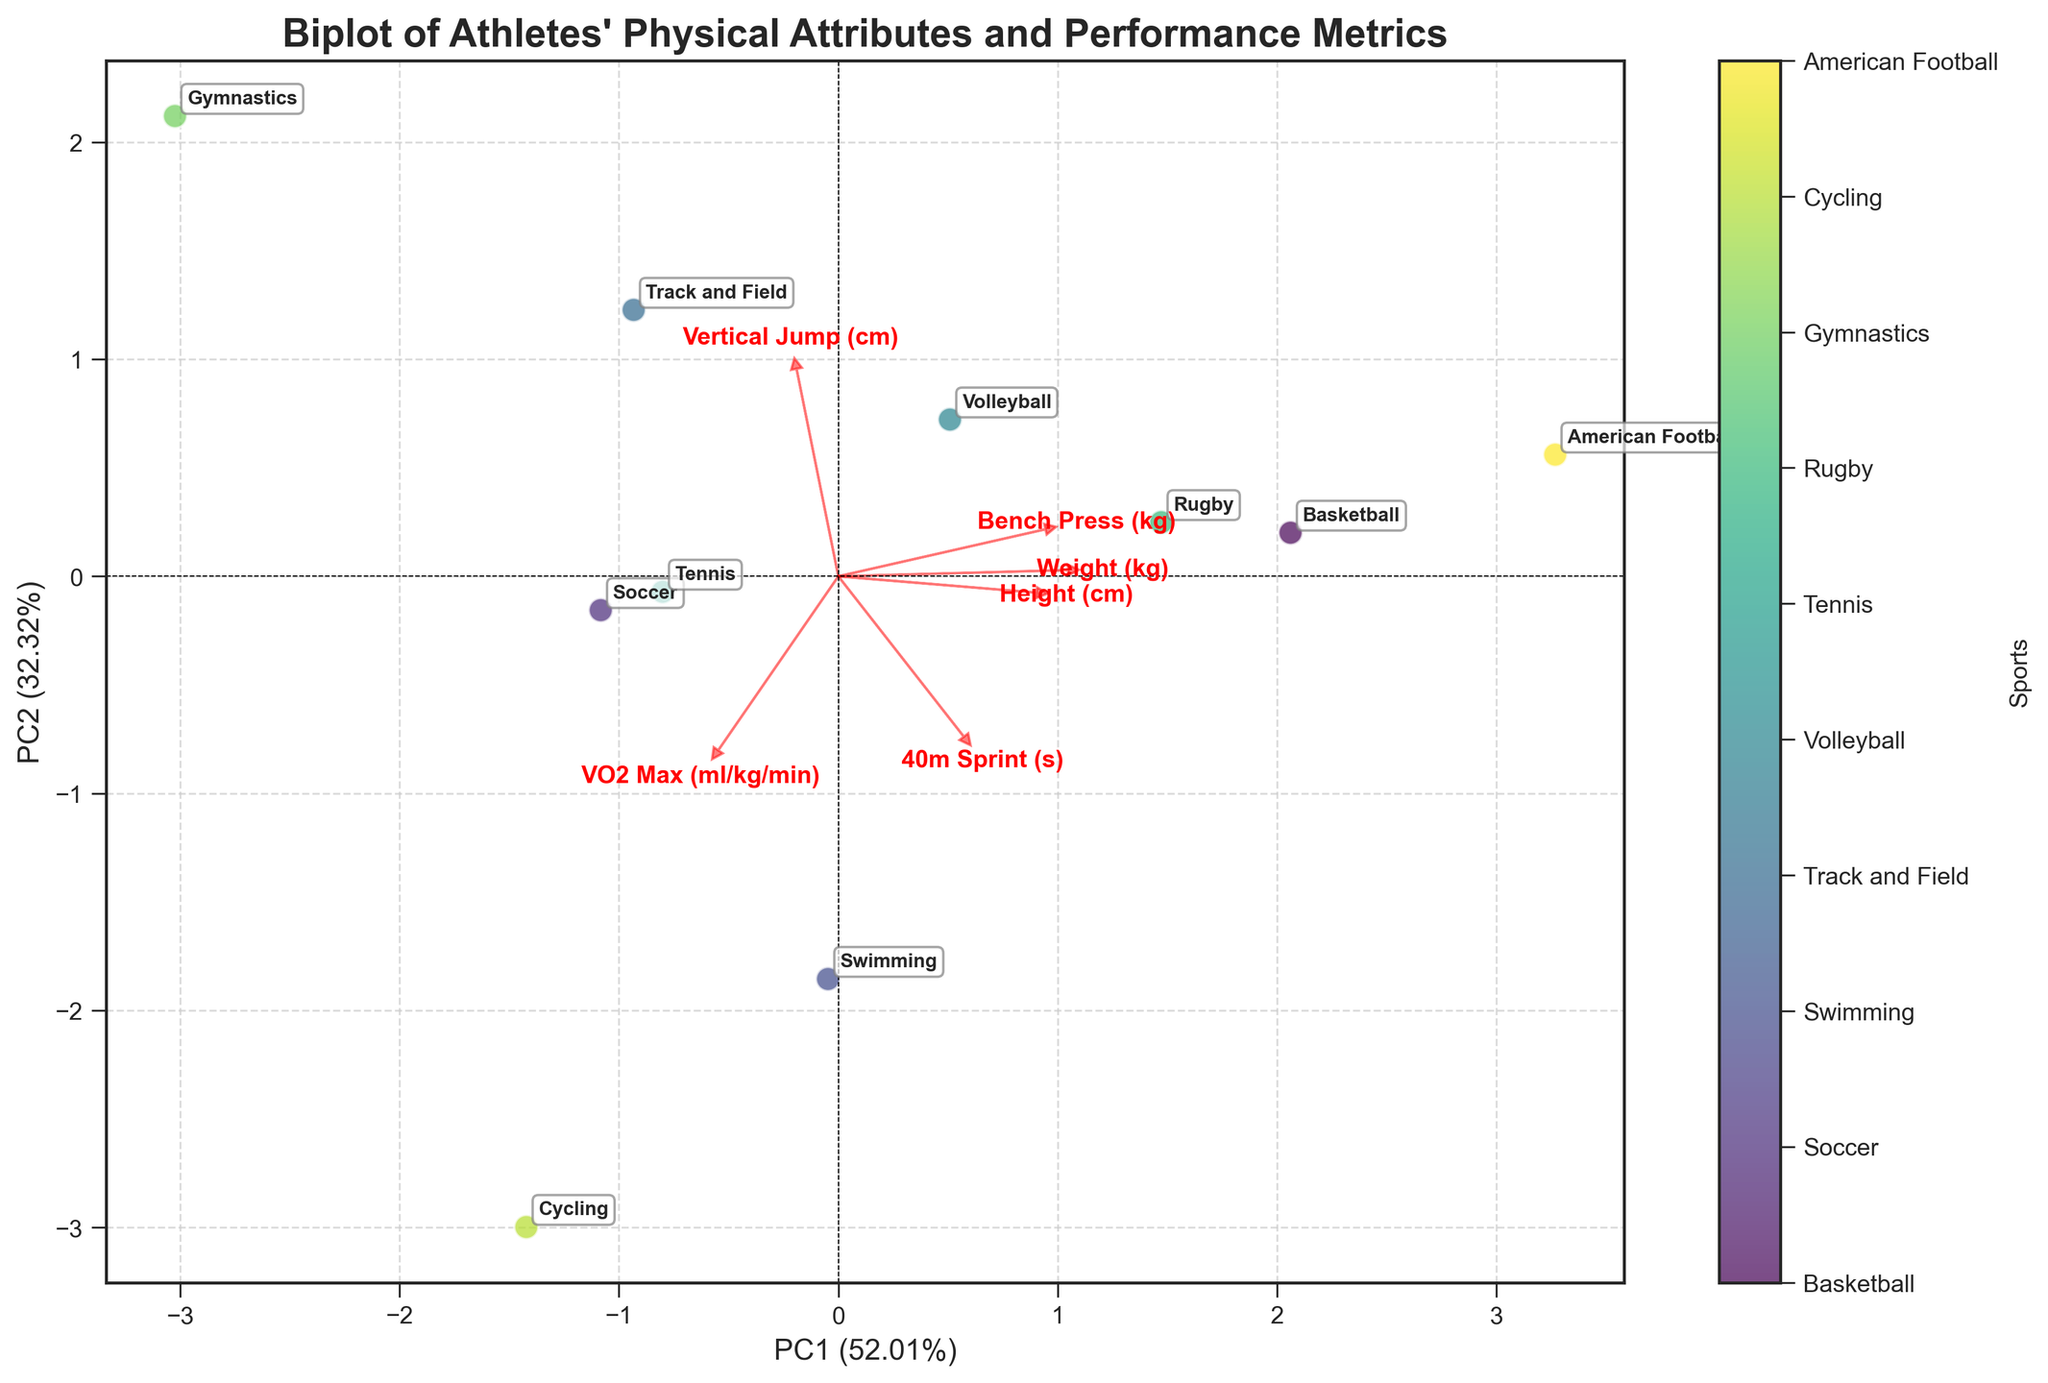what is the title of the figure? The title of the figure is located at the top and is clearly marked and formatted in bold. It reads 'Biplot of Athletes' Physical Attributes and Performance Metrics'.
Answer: Biplot of Athletes' Physical Attributes and Performance Metrics what does the horizontal axis represent? The horizontal axis label indicates PC1 and its explained variance percentage, helping to understand the weight of the component in the dataset variance.
Answer: PC1 Which sport has the highest "40m Sprint" loading along PC1? By looking at the red loadings' arrows, the arrow labeled "40m Sprint (s)" is longest in the direction indicated. This indicates that "Gymnastics" has a high loading on this metric along PC1.
Answer: Gymnastics Which sport appears to have the highest "Vertical Jump"? From the plot annotations, "Gymnastics" is located furthest in the direction of the "Vertical Jump (cm)" loading vector.
Answer: Gymnastics How many data points are there in the figure? Each visible point corresponds to a sport. Upon counting all the unique points on the plot, we get a total number of sports.
Answer: 10 Which metric is most aligned with PC2? By examining which loading vector has the longest projection on the PC2 axis, we find that "VO2 Max (ml/kg/min)" has the most vertical alignment.
Answer: VO2 Max (ml/kg/min) Which two sports are the most similar in terms of their attributes? By observing the clustering of data points, "Basketball" and "American Football" appear closer together than other pairs, indicating more similar attributes.
Answer: Basketball and American Football Which metric appears to have the least influence along both PCs? The shortest loading vector by combining lengths on both axes is "Weight (kg)", indicating it has the least influence among the attributes considered.
Answer: Weight (kg) What is the explained variance of PC1? The axis label for PC1 states the explained variance percentage. PC1 explains .2% of the variance in the data.
Answer: around 40.2% Which sport has the highest overall fitness level based on VO2 Max? By examining the point aligned furthest in the direction of the "VO2 Max" vector, "Cycling" appears to represent the highest overall fitness.
Answer: Cycling 